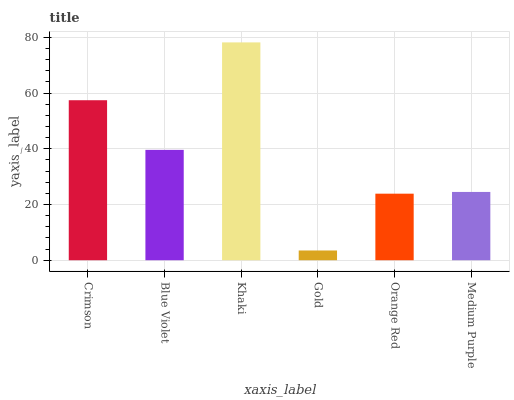Is Gold the minimum?
Answer yes or no. Yes. Is Khaki the maximum?
Answer yes or no. Yes. Is Blue Violet the minimum?
Answer yes or no. No. Is Blue Violet the maximum?
Answer yes or no. No. Is Crimson greater than Blue Violet?
Answer yes or no. Yes. Is Blue Violet less than Crimson?
Answer yes or no. Yes. Is Blue Violet greater than Crimson?
Answer yes or no. No. Is Crimson less than Blue Violet?
Answer yes or no. No. Is Blue Violet the high median?
Answer yes or no. Yes. Is Medium Purple the low median?
Answer yes or no. Yes. Is Khaki the high median?
Answer yes or no. No. Is Gold the low median?
Answer yes or no. No. 